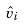Convert formula to latex. <formula><loc_0><loc_0><loc_500><loc_500>\hat { v } _ { i }</formula> 